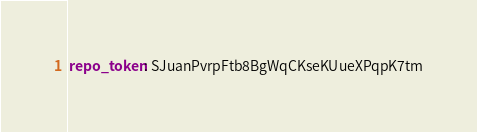Convert code to text. <code><loc_0><loc_0><loc_500><loc_500><_YAML_>repo_token: SJuanPvrpFtb8BgWqCKseKUueXPqpK7tm
</code> 